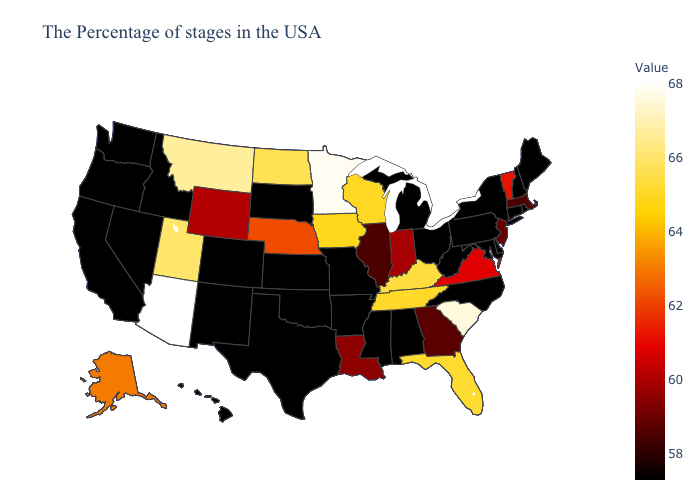Does the map have missing data?
Write a very short answer. No. Does Connecticut have the highest value in the USA?
Keep it brief. No. Which states have the highest value in the USA?
Be succinct. Arizona. Is the legend a continuous bar?
Concise answer only. Yes. Does Arizona have the highest value in the USA?
Answer briefly. Yes. Which states have the lowest value in the Northeast?
Be succinct. Maine, Rhode Island, New Hampshire, Connecticut, New York, Pennsylvania. 